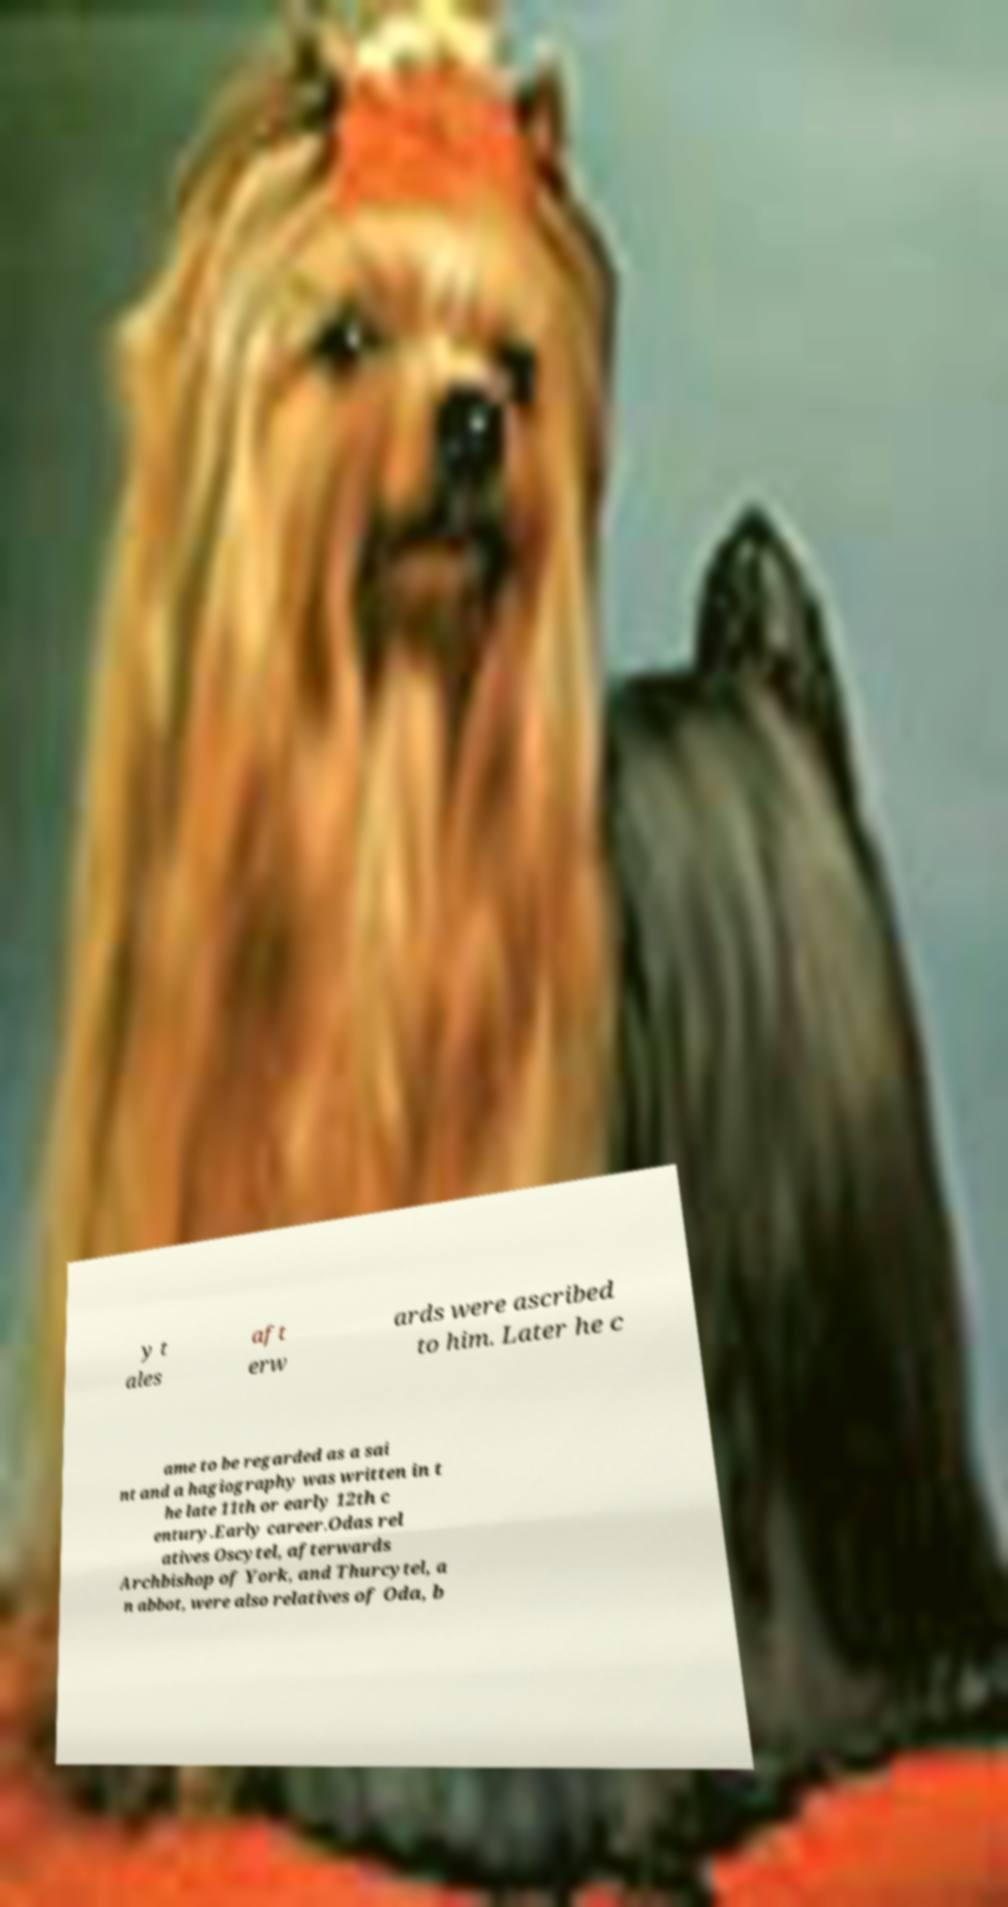Please identify and transcribe the text found in this image. y t ales aft erw ards were ascribed to him. Later he c ame to be regarded as a sai nt and a hagiography was written in t he late 11th or early 12th c entury.Early career.Odas rel atives Oscytel, afterwards Archbishop of York, and Thurcytel, a n abbot, were also relatives of Oda, b 